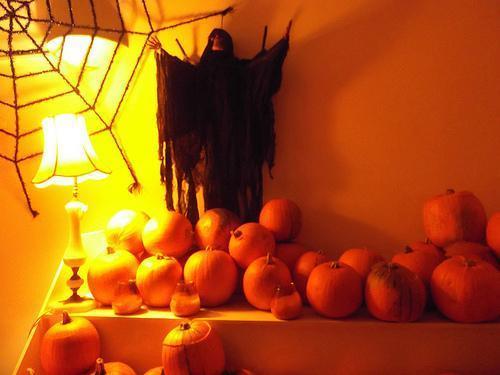How many lights?
Give a very brief answer. 1. 